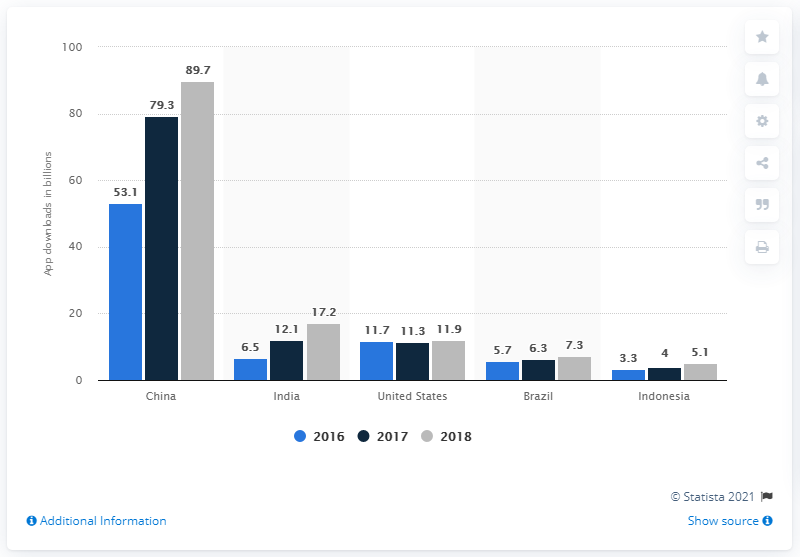Indicate a few pertinent items in this graphic. In 2018, China had approximately 89.7 million mobile app downloads. In 2018, India generated 17.2 mobile app downloads. 